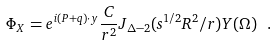Convert formula to latex. <formula><loc_0><loc_0><loc_500><loc_500>\Phi _ { X } = e ^ { i ( P + q ) \cdot y } \frac { C } { r ^ { 2 } } J _ { \Delta - 2 } ( s ^ { 1 / 2 } R ^ { 2 } / r ) Y ( \Omega ) \ .</formula> 